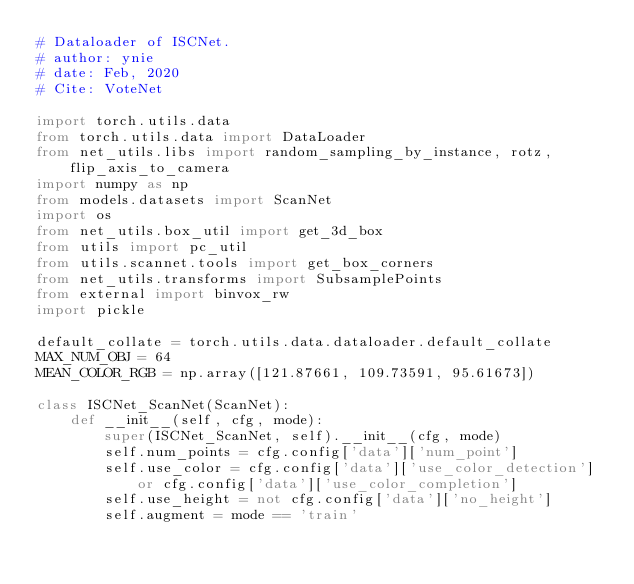Convert code to text. <code><loc_0><loc_0><loc_500><loc_500><_Python_># Dataloader of ISCNet.
# author: ynie
# date: Feb, 2020
# Cite: VoteNet

import torch.utils.data
from torch.utils.data import DataLoader
from net_utils.libs import random_sampling_by_instance, rotz, flip_axis_to_camera
import numpy as np
from models.datasets import ScanNet
import os
from net_utils.box_util import get_3d_box
from utils import pc_util
from utils.scannet.tools import get_box_corners
from net_utils.transforms import SubsamplePoints
from external import binvox_rw
import pickle

default_collate = torch.utils.data.dataloader.default_collate
MAX_NUM_OBJ = 64
MEAN_COLOR_RGB = np.array([121.87661, 109.73591, 95.61673])

class ISCNet_ScanNet(ScanNet):
    def __init__(self, cfg, mode):
        super(ISCNet_ScanNet, self).__init__(cfg, mode)
        self.num_points = cfg.config['data']['num_point']
        self.use_color = cfg.config['data']['use_color_detection'] or cfg.config['data']['use_color_completion']
        self.use_height = not cfg.config['data']['no_height']
        self.augment = mode == 'train'</code> 